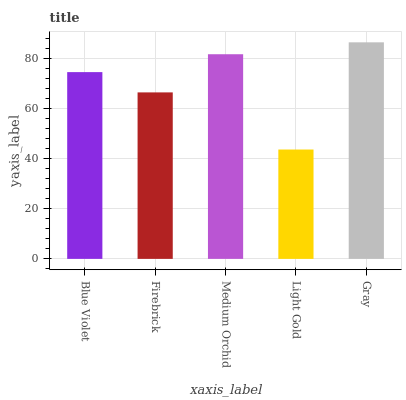Is Light Gold the minimum?
Answer yes or no. Yes. Is Gray the maximum?
Answer yes or no. Yes. Is Firebrick the minimum?
Answer yes or no. No. Is Firebrick the maximum?
Answer yes or no. No. Is Blue Violet greater than Firebrick?
Answer yes or no. Yes. Is Firebrick less than Blue Violet?
Answer yes or no. Yes. Is Firebrick greater than Blue Violet?
Answer yes or no. No. Is Blue Violet less than Firebrick?
Answer yes or no. No. Is Blue Violet the high median?
Answer yes or no. Yes. Is Blue Violet the low median?
Answer yes or no. Yes. Is Firebrick the high median?
Answer yes or no. No. Is Gray the low median?
Answer yes or no. No. 